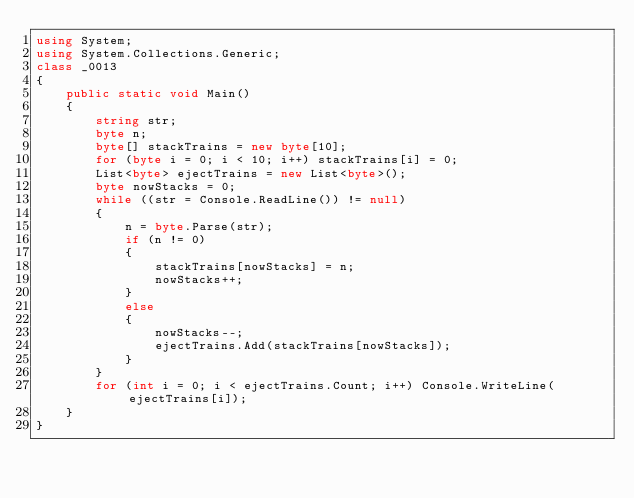<code> <loc_0><loc_0><loc_500><loc_500><_C#_>using System;
using System.Collections.Generic;
class _0013
{
    public static void Main()
    {
        string str;
        byte n;
        byte[] stackTrains = new byte[10];
        for (byte i = 0; i < 10; i++) stackTrains[i] = 0;
        List<byte> ejectTrains = new List<byte>();
        byte nowStacks = 0;
        while ((str = Console.ReadLine()) != null)
        {
            n = byte.Parse(str);
            if (n != 0)
            {
                stackTrains[nowStacks] = n;
                nowStacks++;
            }
            else
            {
                nowStacks--;
                ejectTrains.Add(stackTrains[nowStacks]);
            }
        }
        for (int i = 0; i < ejectTrains.Count; i++) Console.WriteLine(ejectTrains[i]);
    }
}</code> 